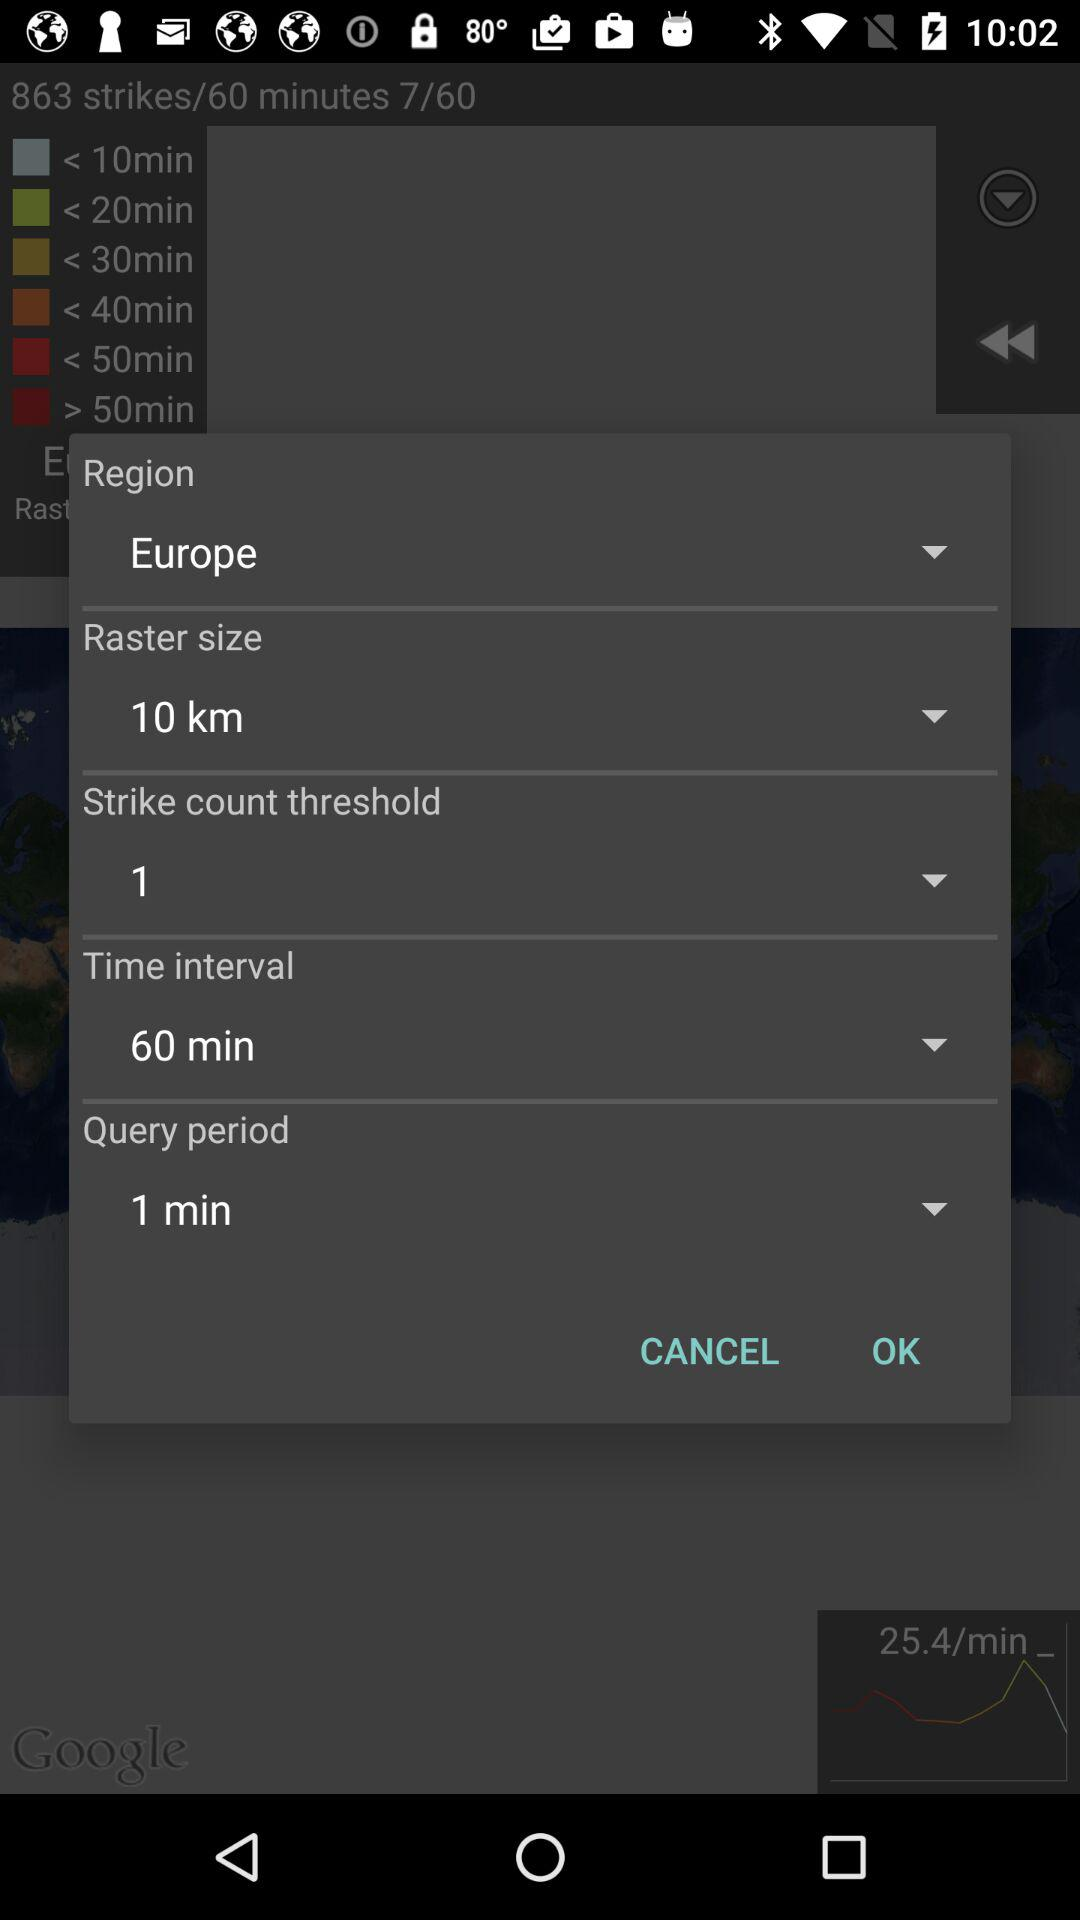What is the query period? The query period is 1 minute. 